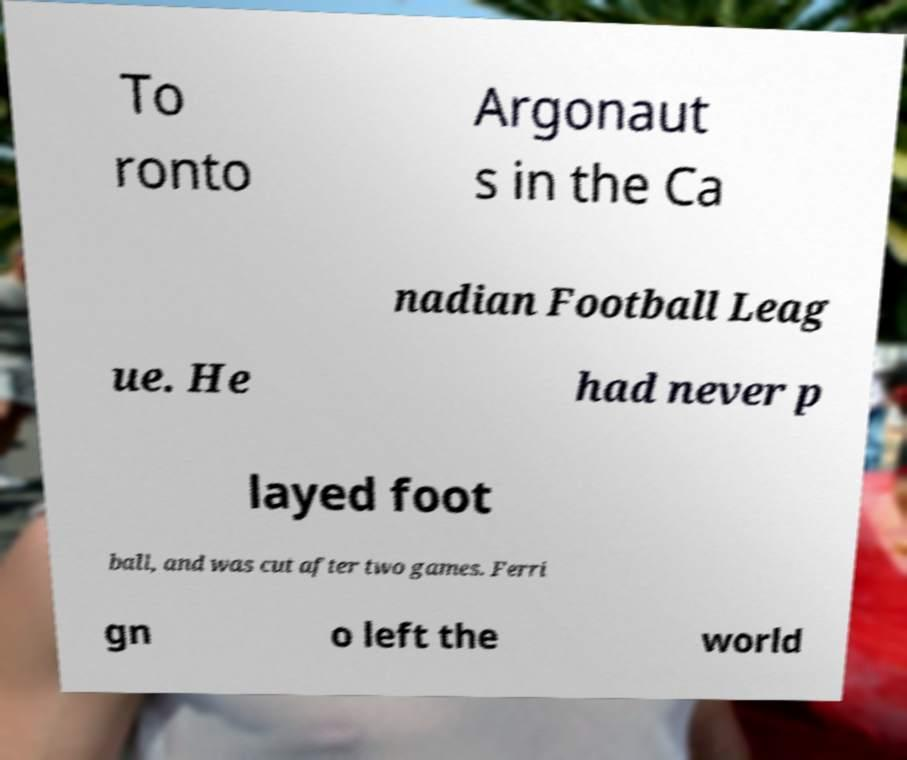There's text embedded in this image that I need extracted. Can you transcribe it verbatim? To ronto Argonaut s in the Ca nadian Football Leag ue. He had never p layed foot ball, and was cut after two games. Ferri gn o left the world 